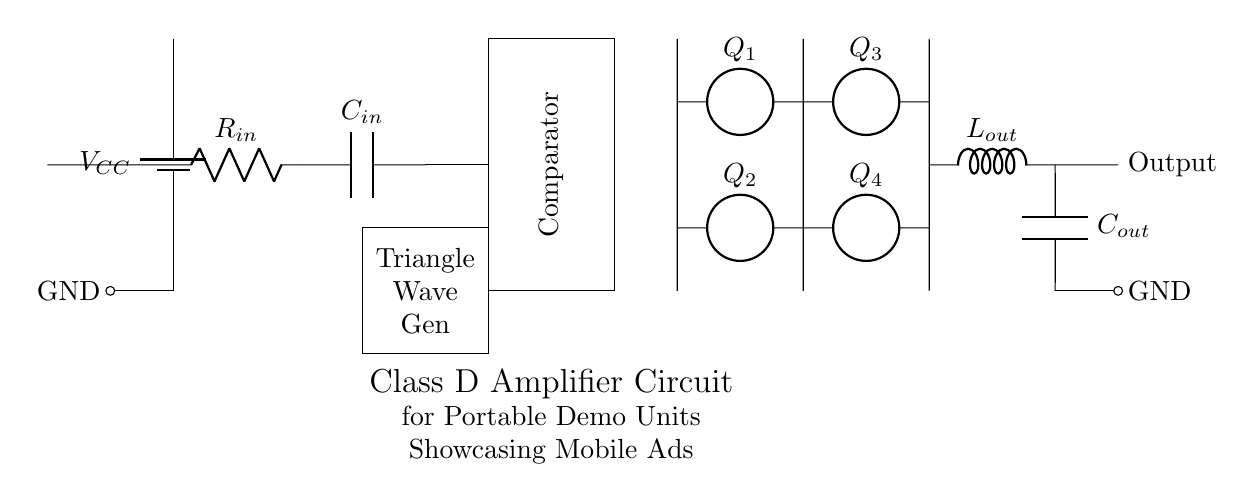What is the power supply voltage in this circuit? The power supply voltage is indicated by the symbol for the battery labeled V_CC, which connects to the circuit at a certain point.
Answer: V_CC What is the role of the triangle wave generator? The triangle wave generator produces a triangular waveform that is essential for determining the switching states of the comparator, thus controlling the output waveform.
Answer: Triangle wave generation How many output capacitors are present in this circuit? The diagram shows one output capacitor labeled C_out connected between the output and ground, implying there is a single output capacitor in the circuit.
Answer: One What are the four components labeled Q_1, Q_2, Q_3, and Q_4? These components represent a set of four switches, typically MOSFETs or transistors, arranged in an H-bridge configuration to control the output to the load.
Answer: H-bridge switches How is the input current regulated in this circuit? The input current is regulated through a resistor R_in, which limits the amount of current that flows into the input stage of the amplifier, ensuring a controlled operation of the amplifier.
Answer: Through resistor What does L_out represent in this circuit? L_out is labeled as an inductor in the circuit, which is typically used in class D amplifiers to filter the output, smoothing the switching signals into a more sinusoidal waveform suitable for driving speakers.
Answer: Inductor for filtering 